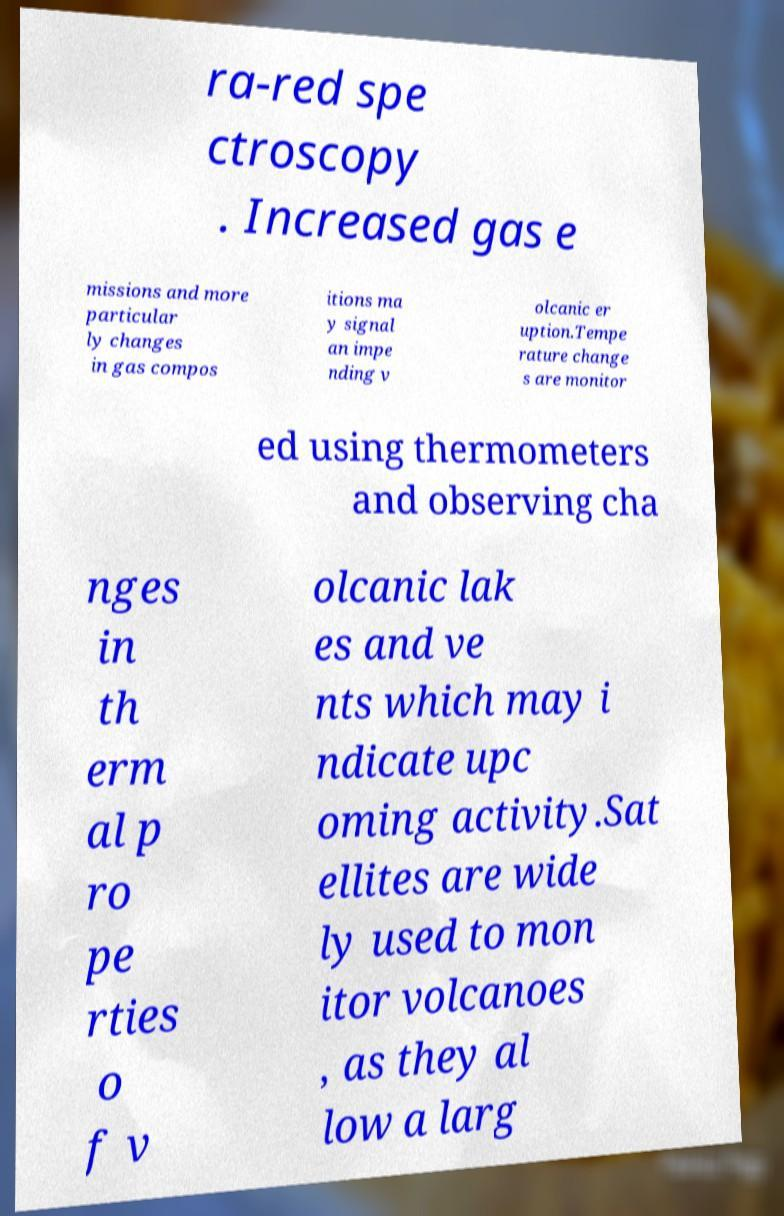I need the written content from this picture converted into text. Can you do that? ra-red spe ctroscopy . Increased gas e missions and more particular ly changes in gas compos itions ma y signal an impe nding v olcanic er uption.Tempe rature change s are monitor ed using thermometers and observing cha nges in th erm al p ro pe rties o f v olcanic lak es and ve nts which may i ndicate upc oming activity.Sat ellites are wide ly used to mon itor volcanoes , as they al low a larg 